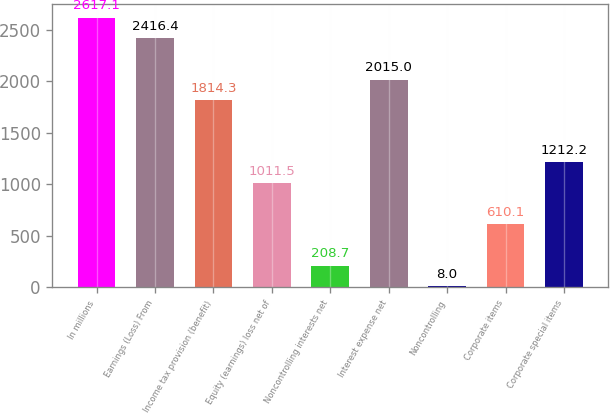<chart> <loc_0><loc_0><loc_500><loc_500><bar_chart><fcel>In millions<fcel>Earnings (Loss) From<fcel>Income tax provision (benefit)<fcel>Equity (earnings) loss net of<fcel>Noncontrolling interests net<fcel>Interest expense net<fcel>Noncontrolling<fcel>Corporate items<fcel>Corporate special items<nl><fcel>2617.1<fcel>2416.4<fcel>1814.3<fcel>1011.5<fcel>208.7<fcel>2015<fcel>8<fcel>610.1<fcel>1212.2<nl></chart> 